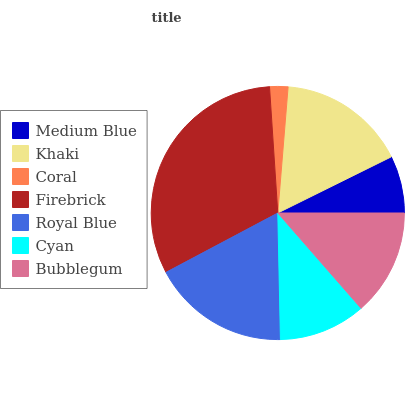Is Coral the minimum?
Answer yes or no. Yes. Is Firebrick the maximum?
Answer yes or no. Yes. Is Khaki the minimum?
Answer yes or no. No. Is Khaki the maximum?
Answer yes or no. No. Is Khaki greater than Medium Blue?
Answer yes or no. Yes. Is Medium Blue less than Khaki?
Answer yes or no. Yes. Is Medium Blue greater than Khaki?
Answer yes or no. No. Is Khaki less than Medium Blue?
Answer yes or no. No. Is Bubblegum the high median?
Answer yes or no. Yes. Is Bubblegum the low median?
Answer yes or no. Yes. Is Khaki the high median?
Answer yes or no. No. Is Royal Blue the low median?
Answer yes or no. No. 